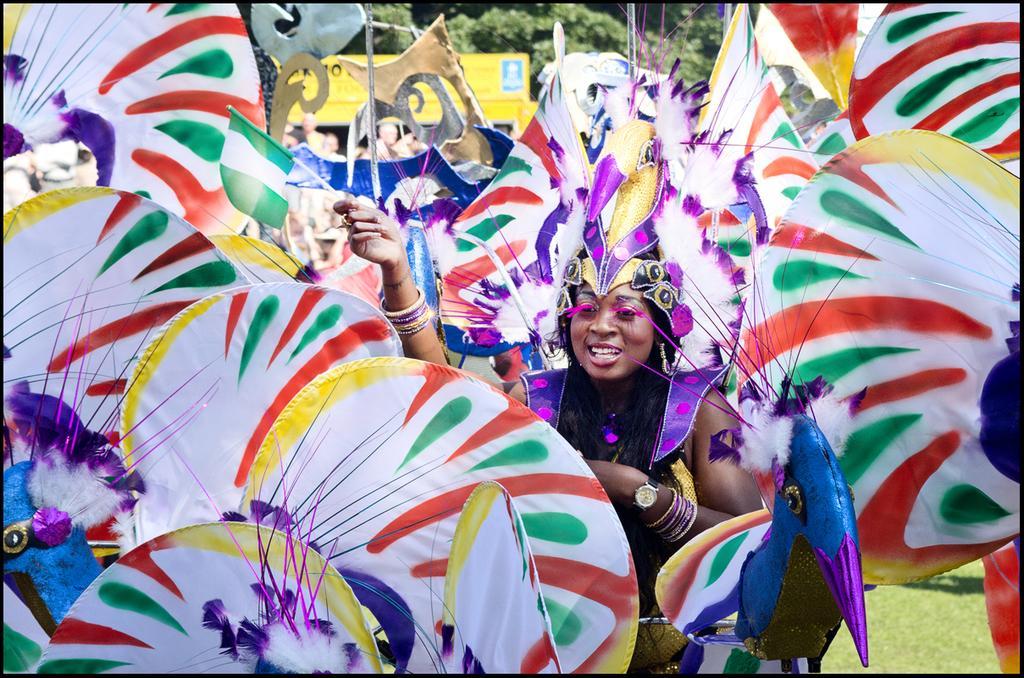Describe this image in one or two sentences. In this image I can see a woman wearing purple and black colored dress is holding a flag in her hand. I can see few colorful objects around her. In the background I can see few trees and a yellow colored object. 